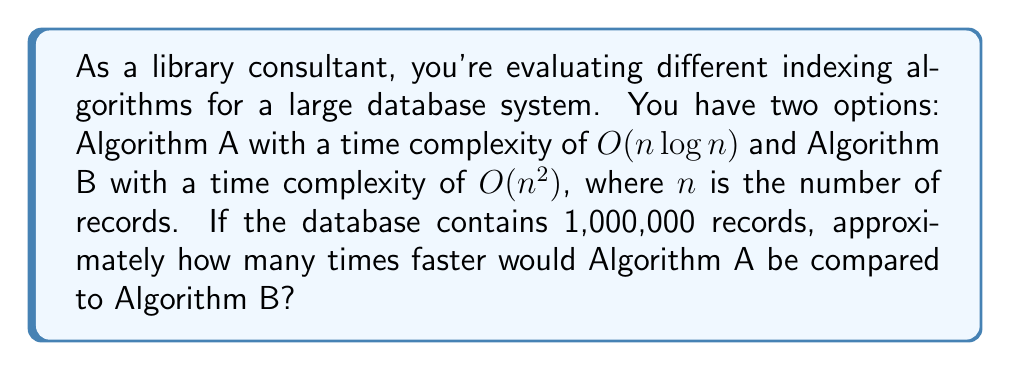Can you solve this math problem? To compare the efficiency of these algorithms, we'll follow these steps:

1. Express the time complexities in terms of $n = 1,000,000$:
   Algorithm A: $O(n \log n) = O(1,000,000 \log 1,000,000)$
   Algorithm B: $O(n^2) = O(1,000,000^2)$

2. Calculate $\log 1,000,000$:
   $\log 1,000,000 \approx 20$ (using base-2 logarithm)

3. Approximate the number of operations for each algorithm:
   Algorithm A: $1,000,000 \times 20 = 20,000,000$ operations
   Algorithm B: $1,000,000^2 = 1,000,000,000,000$ operations

4. Calculate the ratio of operations:
   $\frac{\text{Algorithm B operations}}{\text{Algorithm A operations}} = \frac{1,000,000,000,000}{20,000,000} = 50,000$

Therefore, Algorithm A would be approximately 50,000 times faster than Algorithm B for a database with 1,000,000 records.
Answer: 50,000 times faster 